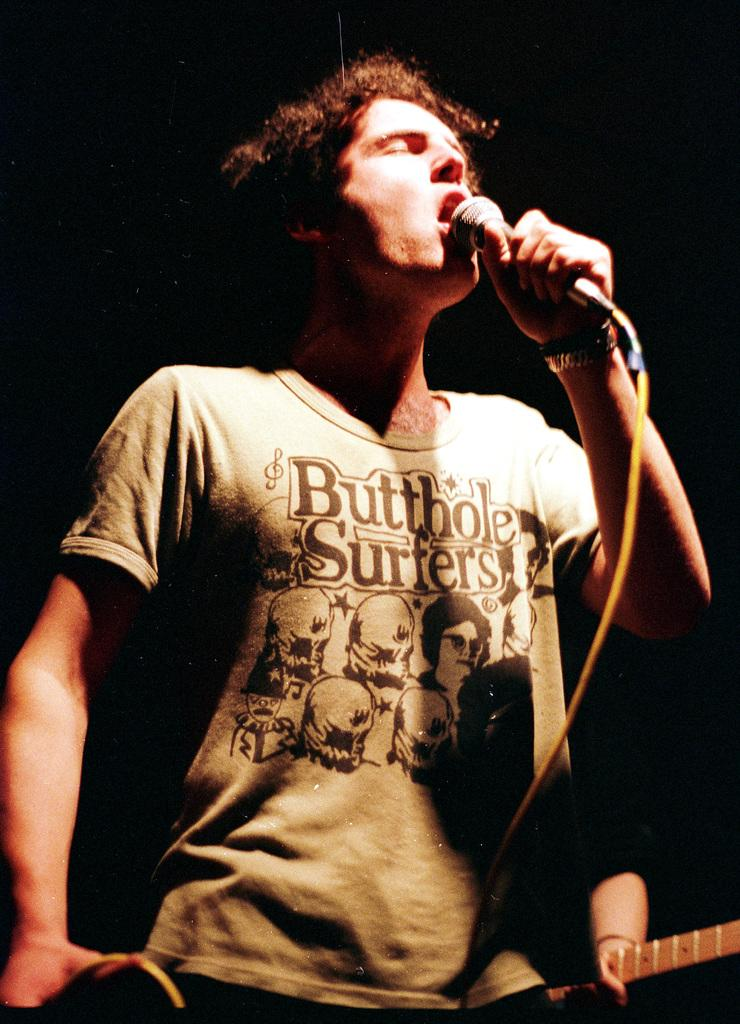What is the main subject of the image? The main subject of the image is a man. What is the man wearing? The man is wearing a t-shirt. What is the man holding in the image? The man is holding a microphone. What is the man doing in the image? The man is singing. Can you describe the other person in the image? Yes, there is another person in the image, and they are holding a musical instrument. Can you see any cobwebs in the image? There is no mention of cobwebs in the provided facts, and therefore we cannot determine if any are present in the image. What degree does the man in the image have? There is no information about the man's education or degrees in the provided facts, so we cannot answer this question. 